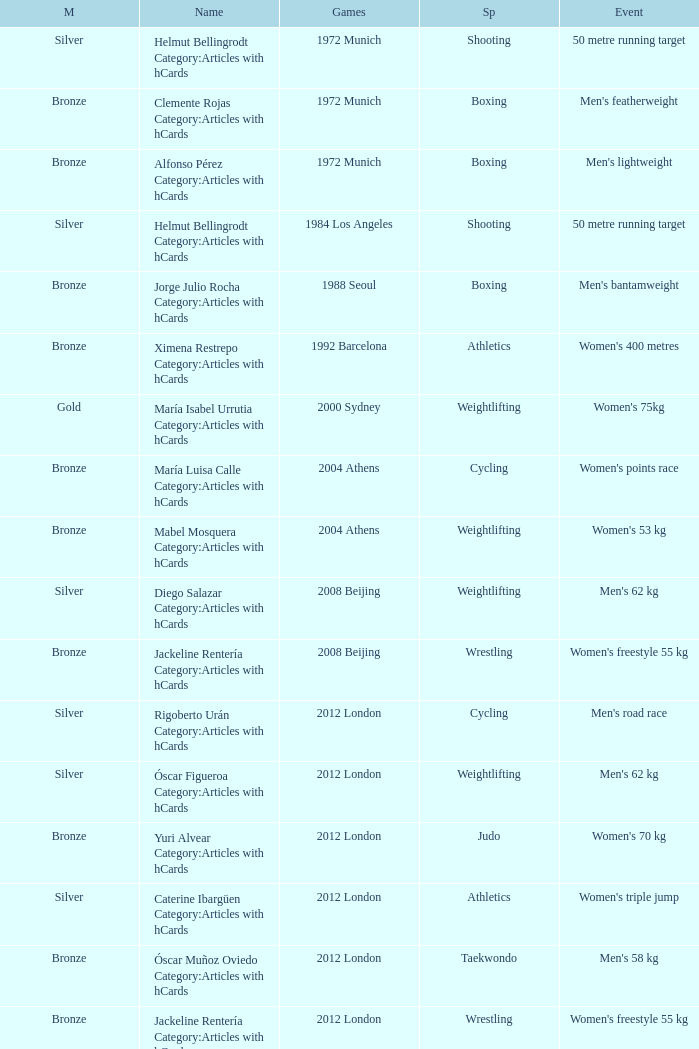Which wrestling event was at the 2008 Beijing games? Women's freestyle 55 kg. 